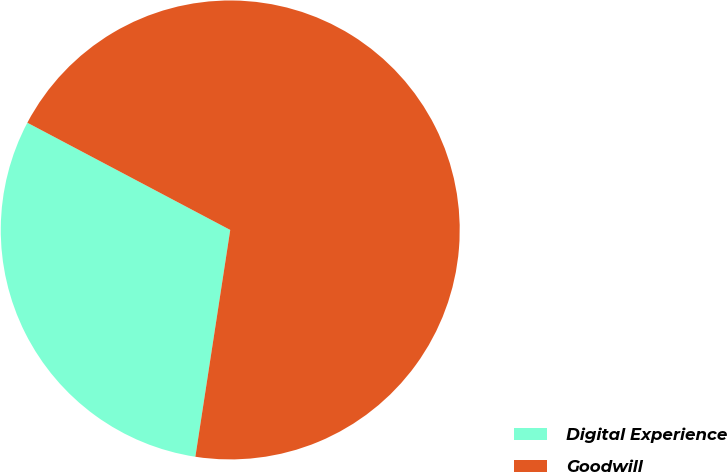Convert chart. <chart><loc_0><loc_0><loc_500><loc_500><pie_chart><fcel>Digital Experience<fcel>Goodwill<nl><fcel>30.31%<fcel>69.69%<nl></chart> 